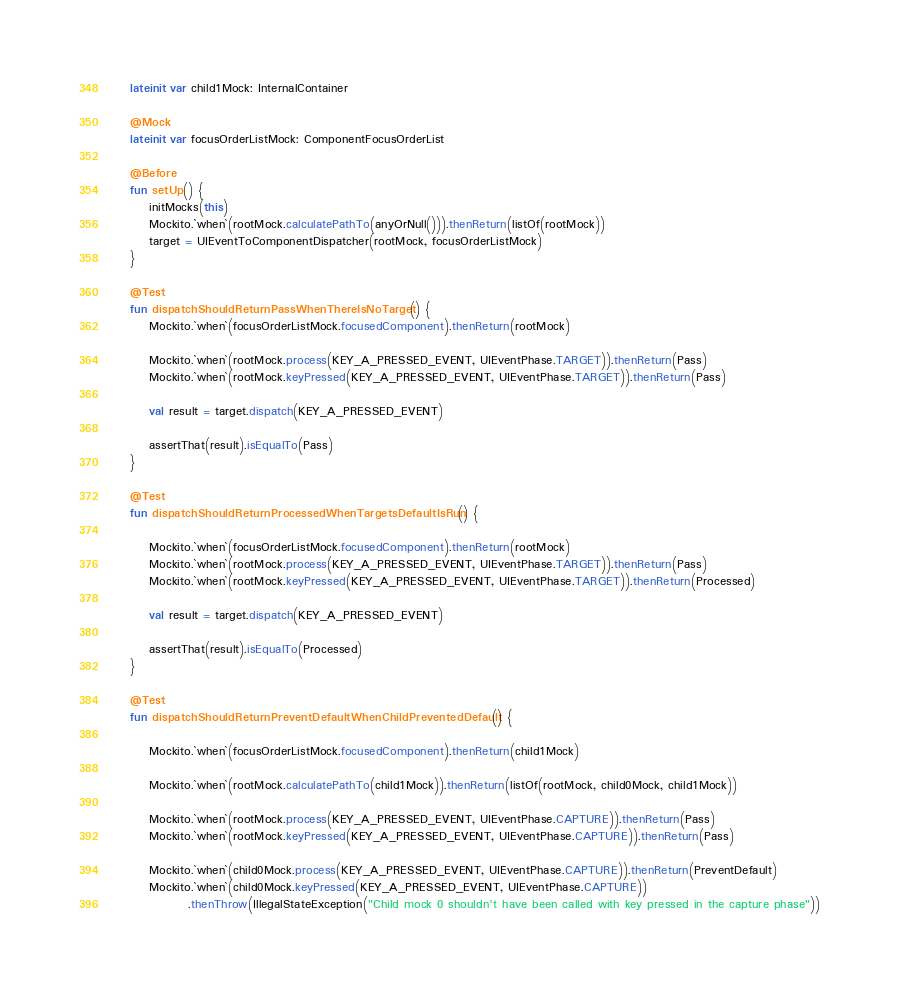<code> <loc_0><loc_0><loc_500><loc_500><_Kotlin_>    lateinit var child1Mock: InternalContainer

    @Mock
    lateinit var focusOrderListMock: ComponentFocusOrderList

    @Before
    fun setUp() {
        initMocks(this)
        Mockito.`when`(rootMock.calculatePathTo(anyOrNull())).thenReturn(listOf(rootMock))
        target = UIEventToComponentDispatcher(rootMock, focusOrderListMock)
    }

    @Test
    fun dispatchShouldReturnPassWhenThereIsNoTarget() {
        Mockito.`when`(focusOrderListMock.focusedComponent).thenReturn(rootMock)

        Mockito.`when`(rootMock.process(KEY_A_PRESSED_EVENT, UIEventPhase.TARGET)).thenReturn(Pass)
        Mockito.`when`(rootMock.keyPressed(KEY_A_PRESSED_EVENT, UIEventPhase.TARGET)).thenReturn(Pass)

        val result = target.dispatch(KEY_A_PRESSED_EVENT)

        assertThat(result).isEqualTo(Pass)
    }

    @Test
    fun dispatchShouldReturnProcessedWhenTargetsDefaultIsRun() {

        Mockito.`when`(focusOrderListMock.focusedComponent).thenReturn(rootMock)
        Mockito.`when`(rootMock.process(KEY_A_PRESSED_EVENT, UIEventPhase.TARGET)).thenReturn(Pass)
        Mockito.`when`(rootMock.keyPressed(KEY_A_PRESSED_EVENT, UIEventPhase.TARGET)).thenReturn(Processed)

        val result = target.dispatch(KEY_A_PRESSED_EVENT)

        assertThat(result).isEqualTo(Processed)
    }

    @Test
    fun dispatchShouldReturnPreventDefaultWhenChildPreventedDefault() {

        Mockito.`when`(focusOrderListMock.focusedComponent).thenReturn(child1Mock)

        Mockito.`when`(rootMock.calculatePathTo(child1Mock)).thenReturn(listOf(rootMock, child0Mock, child1Mock))

        Mockito.`when`(rootMock.process(KEY_A_PRESSED_EVENT, UIEventPhase.CAPTURE)).thenReturn(Pass)
        Mockito.`when`(rootMock.keyPressed(KEY_A_PRESSED_EVENT, UIEventPhase.CAPTURE)).thenReturn(Pass)

        Mockito.`when`(child0Mock.process(KEY_A_PRESSED_EVENT, UIEventPhase.CAPTURE)).thenReturn(PreventDefault)
        Mockito.`when`(child0Mock.keyPressed(KEY_A_PRESSED_EVENT, UIEventPhase.CAPTURE))
                .thenThrow(IllegalStateException("Child mock 0 shouldn't have been called with key pressed in the capture phase"))
</code> 